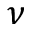Convert formula to latex. <formula><loc_0><loc_0><loc_500><loc_500>\nu</formula> 